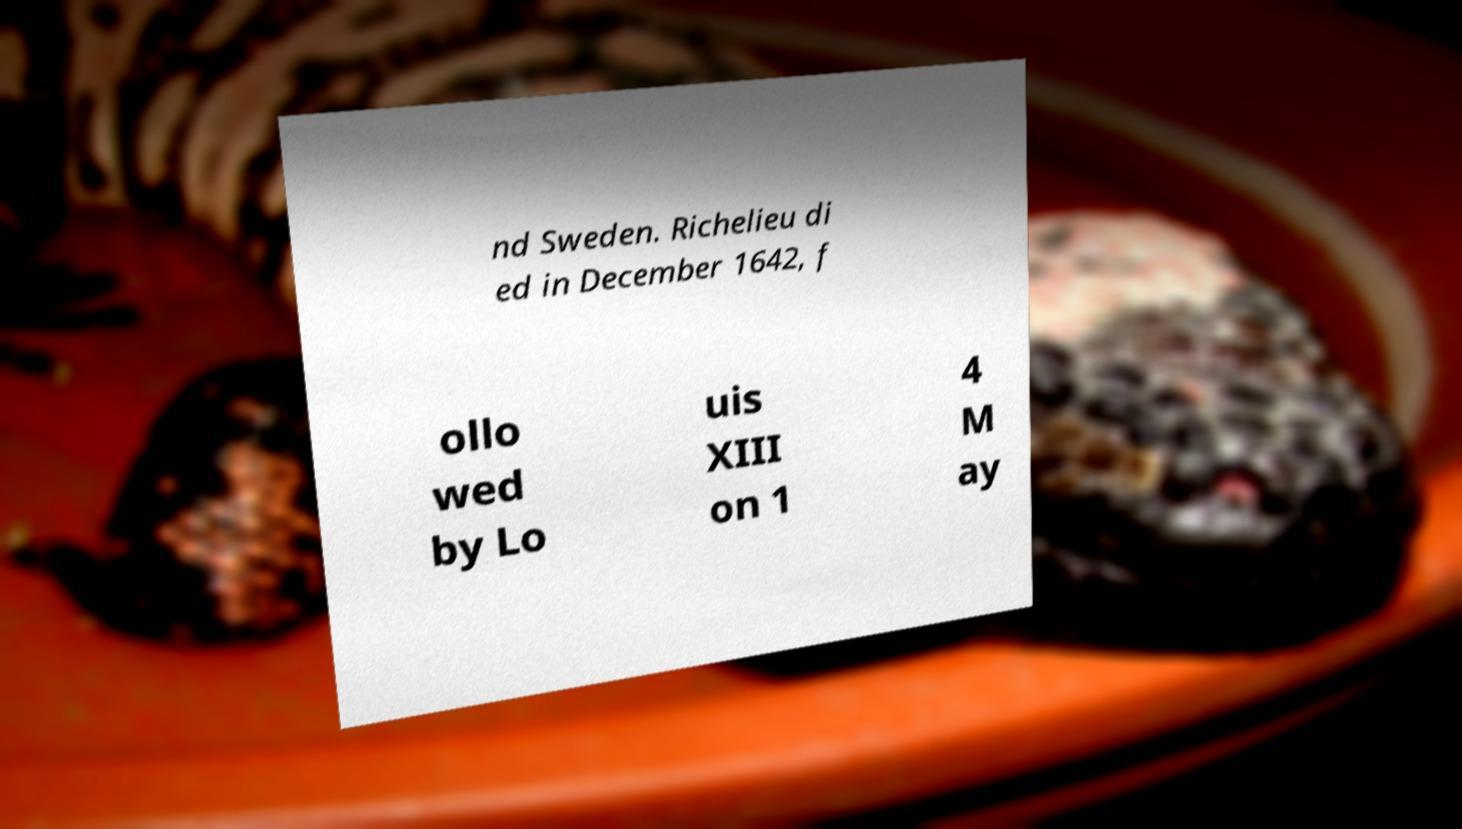Can you accurately transcribe the text from the provided image for me? nd Sweden. Richelieu di ed in December 1642, f ollo wed by Lo uis XIII on 1 4 M ay 